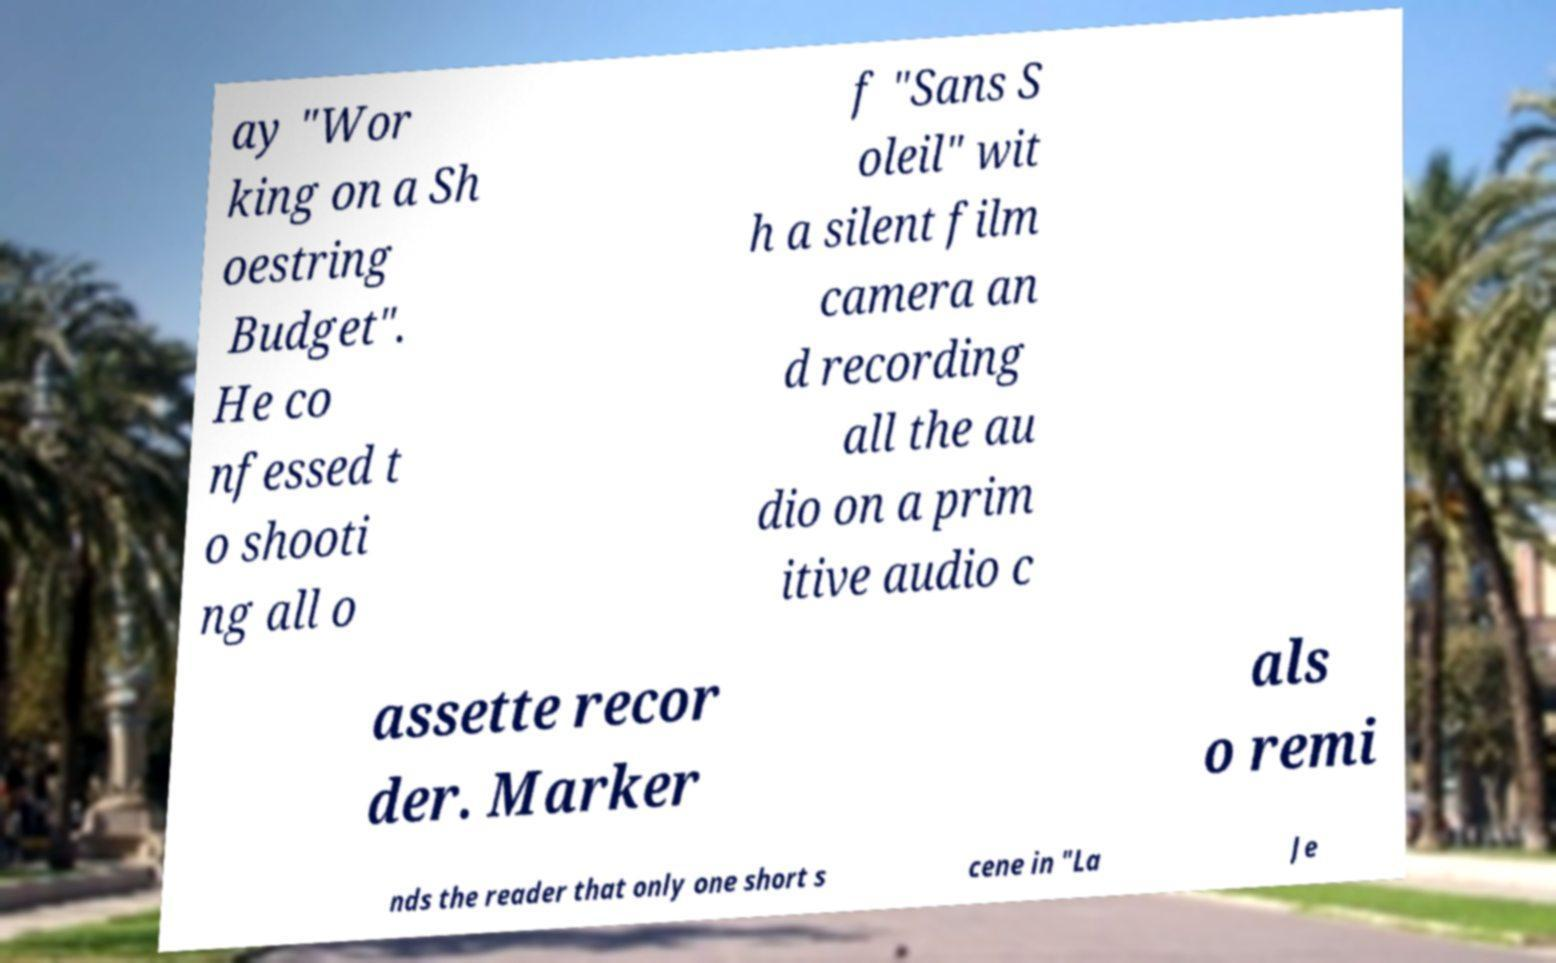What messages or text are displayed in this image? I need them in a readable, typed format. ay "Wor king on a Sh oestring Budget". He co nfessed t o shooti ng all o f "Sans S oleil" wit h a silent film camera an d recording all the au dio on a prim itive audio c assette recor der. Marker als o remi nds the reader that only one short s cene in "La Je 